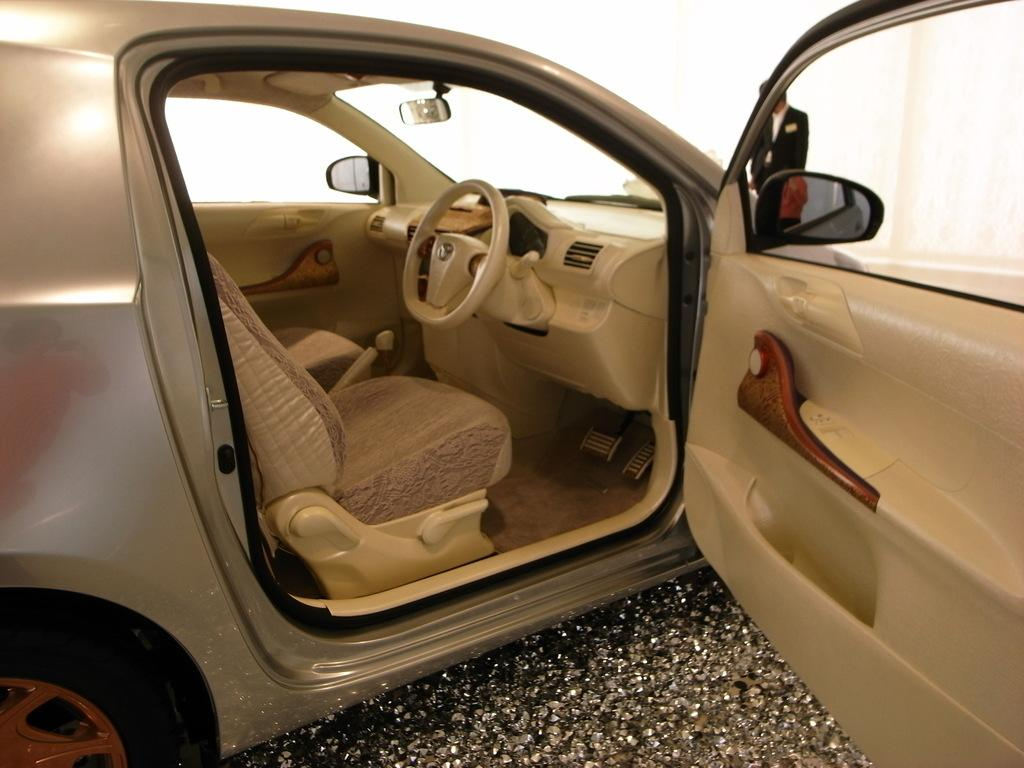What is the main subject of the image? The main subject of the image is a car. How is the car positioned in the image? The car is parked on the ground. What is the status of the car's front door? The front door of the car is open. Can you describe the person in the image? There is a person standing behind the car. What type of oatmeal is being served at the party in the image? There is no party or oatmeal present in the image; it features a parked car with its front door open and a person standing behind it. 